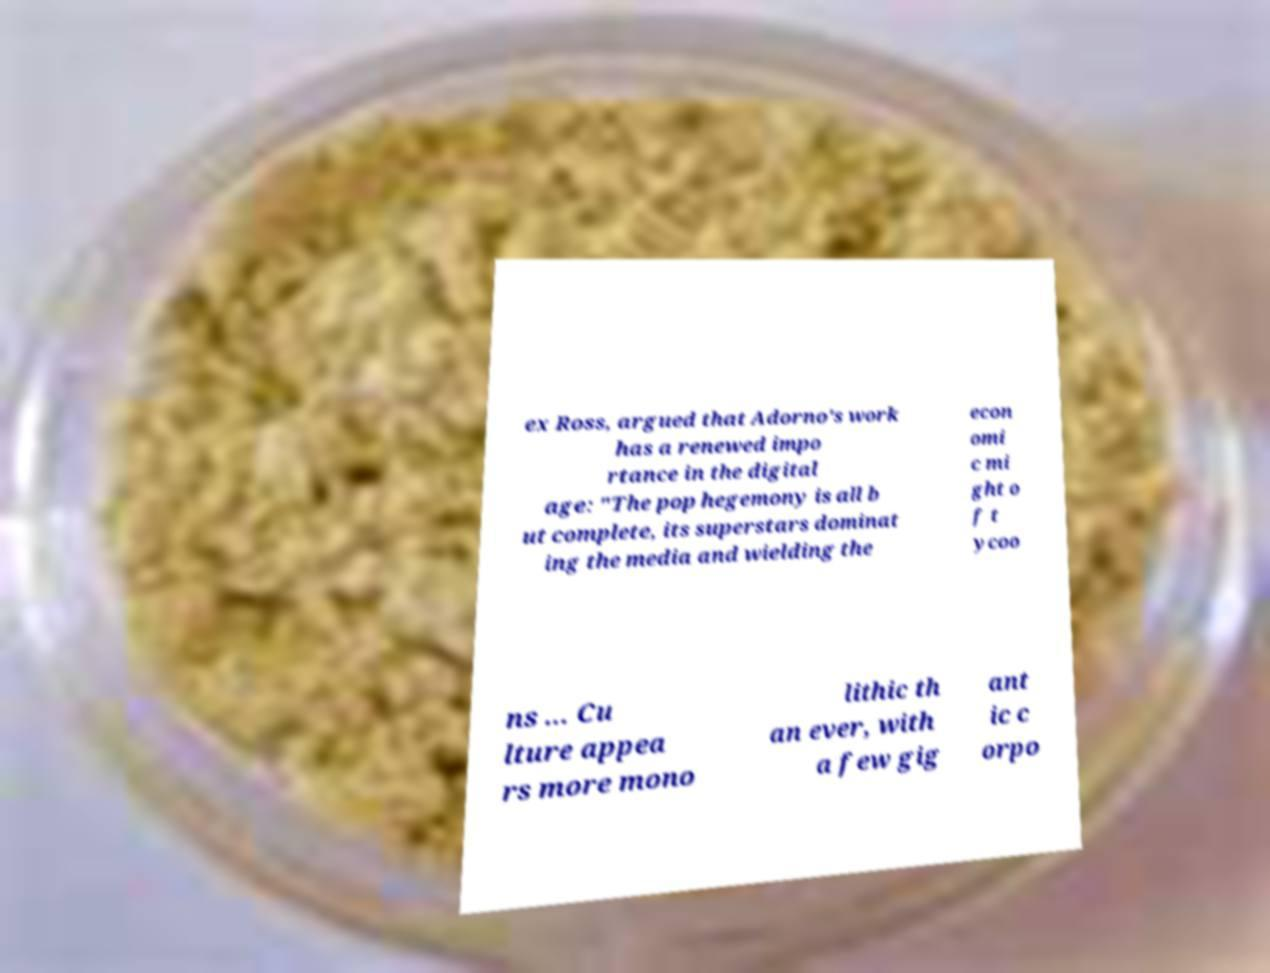Can you accurately transcribe the text from the provided image for me? ex Ross, argued that Adorno's work has a renewed impo rtance in the digital age: "The pop hegemony is all b ut complete, its superstars dominat ing the media and wielding the econ omi c mi ght o f t ycoo ns ... Cu lture appea rs more mono lithic th an ever, with a few gig ant ic c orpo 